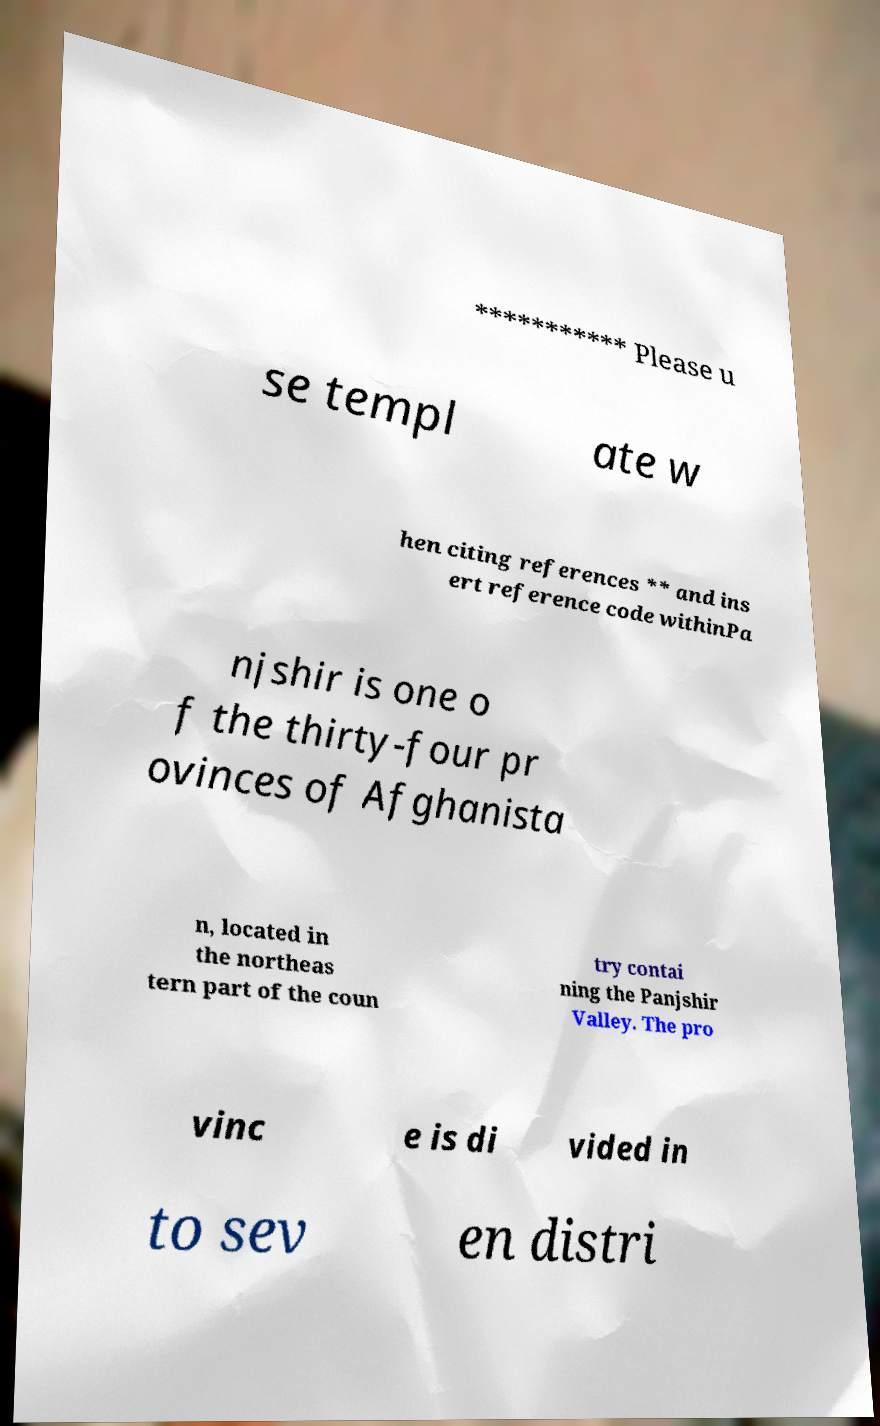Can you read and provide the text displayed in the image?This photo seems to have some interesting text. Can you extract and type it out for me? *********** Please u se templ ate w hen citing references ** and ins ert reference code withinPa njshir is one o f the thirty-four pr ovinces of Afghanista n, located in the northeas tern part of the coun try contai ning the Panjshir Valley. The pro vinc e is di vided in to sev en distri 